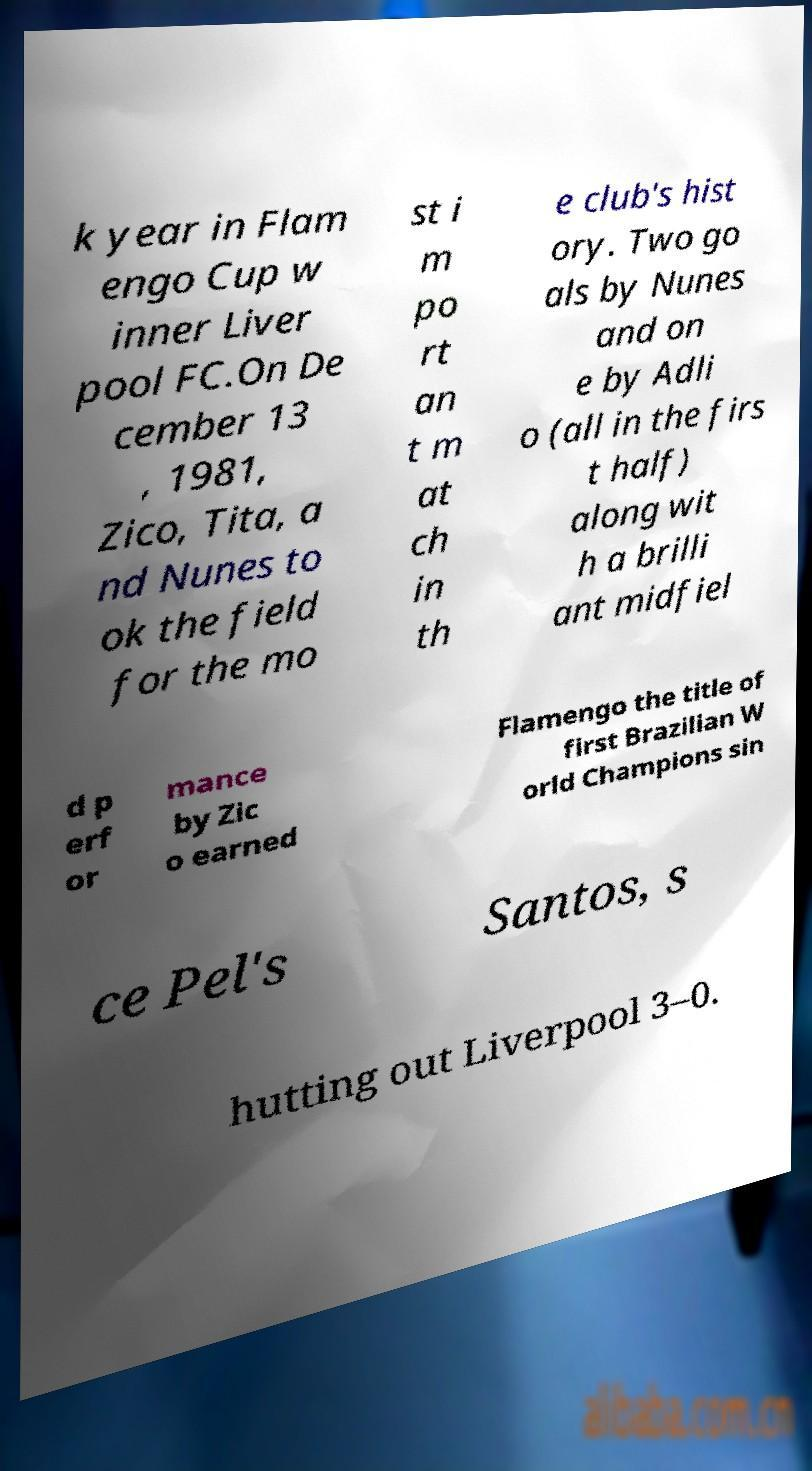Please read and relay the text visible in this image. What does it say? k year in Flam engo Cup w inner Liver pool FC.On De cember 13 , 1981, Zico, Tita, a nd Nunes to ok the field for the mo st i m po rt an t m at ch in th e club's hist ory. Two go als by Nunes and on e by Adli o (all in the firs t half) along wit h a brilli ant midfiel d p erf or mance by Zic o earned Flamengo the title of first Brazilian W orld Champions sin ce Pel's Santos, s hutting out Liverpool 3–0. 